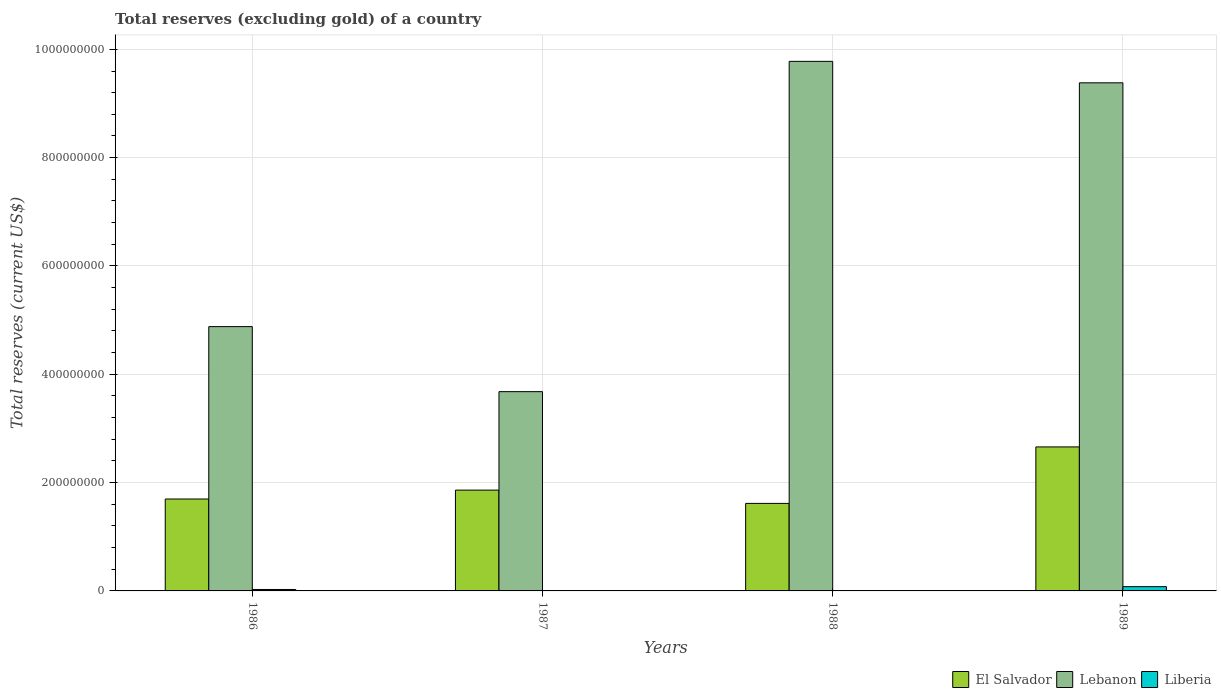How many different coloured bars are there?
Provide a succinct answer. 3. How many groups of bars are there?
Your response must be concise. 4. Are the number of bars on each tick of the X-axis equal?
Offer a terse response. Yes. What is the label of the 4th group of bars from the left?
Provide a succinct answer. 1989. In how many cases, is the number of bars for a given year not equal to the number of legend labels?
Your response must be concise. 0. What is the total reserves (excluding gold) in Liberia in 1988?
Provide a short and direct response. 3.80e+05. Across all years, what is the maximum total reserves (excluding gold) in El Salvador?
Your answer should be compact. 2.66e+08. Across all years, what is the minimum total reserves (excluding gold) in El Salvador?
Give a very brief answer. 1.62e+08. What is the total total reserves (excluding gold) in Lebanon in the graph?
Your answer should be very brief. 2.77e+09. What is the difference between the total reserves (excluding gold) in Lebanon in 1986 and that in 1987?
Keep it short and to the point. 1.20e+08. What is the difference between the total reserves (excluding gold) in Liberia in 1986 and the total reserves (excluding gold) in Lebanon in 1989?
Keep it short and to the point. -9.36e+08. What is the average total reserves (excluding gold) in Lebanon per year?
Provide a short and direct response. 6.93e+08. In the year 1988, what is the difference between the total reserves (excluding gold) in Lebanon and total reserves (excluding gold) in El Salvador?
Provide a short and direct response. 8.16e+08. What is the ratio of the total reserves (excluding gold) in Lebanon in 1986 to that in 1988?
Ensure brevity in your answer.  0.5. Is the total reserves (excluding gold) in El Salvador in 1987 less than that in 1988?
Keep it short and to the point. No. What is the difference between the highest and the second highest total reserves (excluding gold) in Lebanon?
Provide a succinct answer. 3.97e+07. What is the difference between the highest and the lowest total reserves (excluding gold) in El Salvador?
Offer a very short reply. 1.04e+08. Is the sum of the total reserves (excluding gold) in Lebanon in 1987 and 1989 greater than the maximum total reserves (excluding gold) in El Salvador across all years?
Offer a terse response. Yes. What does the 1st bar from the left in 1989 represents?
Ensure brevity in your answer.  El Salvador. What does the 2nd bar from the right in 1987 represents?
Keep it short and to the point. Lebanon. How many bars are there?
Provide a short and direct response. 12. Are the values on the major ticks of Y-axis written in scientific E-notation?
Give a very brief answer. No. Where does the legend appear in the graph?
Offer a terse response. Bottom right. How are the legend labels stacked?
Your response must be concise. Horizontal. What is the title of the graph?
Make the answer very short. Total reserves (excluding gold) of a country. What is the label or title of the X-axis?
Ensure brevity in your answer.  Years. What is the label or title of the Y-axis?
Keep it short and to the point. Total reserves (current US$). What is the Total reserves (current US$) in El Salvador in 1986?
Ensure brevity in your answer.  1.70e+08. What is the Total reserves (current US$) in Lebanon in 1986?
Offer a very short reply. 4.88e+08. What is the Total reserves (current US$) in Liberia in 1986?
Ensure brevity in your answer.  2.66e+06. What is the Total reserves (current US$) in El Salvador in 1987?
Provide a succinct answer. 1.86e+08. What is the Total reserves (current US$) in Lebanon in 1987?
Give a very brief answer. 3.68e+08. What is the Total reserves (current US$) in Liberia in 1987?
Your answer should be compact. 5.10e+05. What is the Total reserves (current US$) in El Salvador in 1988?
Offer a very short reply. 1.62e+08. What is the Total reserves (current US$) of Lebanon in 1988?
Your answer should be very brief. 9.78e+08. What is the Total reserves (current US$) of Liberia in 1988?
Keep it short and to the point. 3.80e+05. What is the Total reserves (current US$) of El Salvador in 1989?
Your answer should be very brief. 2.66e+08. What is the Total reserves (current US$) of Lebanon in 1989?
Your response must be concise. 9.38e+08. What is the Total reserves (current US$) in Liberia in 1989?
Give a very brief answer. 7.88e+06. Across all years, what is the maximum Total reserves (current US$) of El Salvador?
Keep it short and to the point. 2.66e+08. Across all years, what is the maximum Total reserves (current US$) in Lebanon?
Your response must be concise. 9.78e+08. Across all years, what is the maximum Total reserves (current US$) in Liberia?
Provide a short and direct response. 7.88e+06. Across all years, what is the minimum Total reserves (current US$) in El Salvador?
Provide a succinct answer. 1.62e+08. Across all years, what is the minimum Total reserves (current US$) in Lebanon?
Your answer should be compact. 3.68e+08. Across all years, what is the minimum Total reserves (current US$) in Liberia?
Offer a very short reply. 3.80e+05. What is the total Total reserves (current US$) in El Salvador in the graph?
Offer a terse response. 7.83e+08. What is the total Total reserves (current US$) of Lebanon in the graph?
Give a very brief answer. 2.77e+09. What is the total Total reserves (current US$) of Liberia in the graph?
Make the answer very short. 1.14e+07. What is the difference between the Total reserves (current US$) of El Salvador in 1986 and that in 1987?
Provide a succinct answer. -1.64e+07. What is the difference between the Total reserves (current US$) of Lebanon in 1986 and that in 1987?
Give a very brief answer. 1.20e+08. What is the difference between the Total reserves (current US$) of Liberia in 1986 and that in 1987?
Provide a short and direct response. 2.15e+06. What is the difference between the Total reserves (current US$) of El Salvador in 1986 and that in 1988?
Offer a very short reply. 8.09e+06. What is the difference between the Total reserves (current US$) of Lebanon in 1986 and that in 1988?
Keep it short and to the point. -4.90e+08. What is the difference between the Total reserves (current US$) in Liberia in 1986 and that in 1988?
Your response must be concise. 2.28e+06. What is the difference between the Total reserves (current US$) in El Salvador in 1986 and that in 1989?
Your answer should be compact. -9.62e+07. What is the difference between the Total reserves (current US$) of Lebanon in 1986 and that in 1989?
Your answer should be compact. -4.50e+08. What is the difference between the Total reserves (current US$) of Liberia in 1986 and that in 1989?
Your response must be concise. -5.22e+06. What is the difference between the Total reserves (current US$) in El Salvador in 1987 and that in 1988?
Your answer should be very brief. 2.45e+07. What is the difference between the Total reserves (current US$) of Lebanon in 1987 and that in 1988?
Ensure brevity in your answer.  -6.10e+08. What is the difference between the Total reserves (current US$) of Liberia in 1987 and that in 1988?
Offer a terse response. 1.29e+05. What is the difference between the Total reserves (current US$) in El Salvador in 1987 and that in 1989?
Ensure brevity in your answer.  -7.98e+07. What is the difference between the Total reserves (current US$) of Lebanon in 1987 and that in 1989?
Provide a short and direct response. -5.70e+08. What is the difference between the Total reserves (current US$) of Liberia in 1987 and that in 1989?
Provide a succinct answer. -7.37e+06. What is the difference between the Total reserves (current US$) of El Salvador in 1988 and that in 1989?
Your answer should be compact. -1.04e+08. What is the difference between the Total reserves (current US$) in Lebanon in 1988 and that in 1989?
Provide a short and direct response. 3.97e+07. What is the difference between the Total reserves (current US$) of Liberia in 1988 and that in 1989?
Keep it short and to the point. -7.50e+06. What is the difference between the Total reserves (current US$) in El Salvador in 1986 and the Total reserves (current US$) in Lebanon in 1987?
Your answer should be very brief. -1.98e+08. What is the difference between the Total reserves (current US$) of El Salvador in 1986 and the Total reserves (current US$) of Liberia in 1987?
Offer a terse response. 1.69e+08. What is the difference between the Total reserves (current US$) in Lebanon in 1986 and the Total reserves (current US$) in Liberia in 1987?
Offer a terse response. 4.88e+08. What is the difference between the Total reserves (current US$) of El Salvador in 1986 and the Total reserves (current US$) of Lebanon in 1988?
Ensure brevity in your answer.  -8.08e+08. What is the difference between the Total reserves (current US$) in El Salvador in 1986 and the Total reserves (current US$) in Liberia in 1988?
Your answer should be compact. 1.69e+08. What is the difference between the Total reserves (current US$) of Lebanon in 1986 and the Total reserves (current US$) of Liberia in 1988?
Your response must be concise. 4.88e+08. What is the difference between the Total reserves (current US$) of El Salvador in 1986 and the Total reserves (current US$) of Lebanon in 1989?
Offer a terse response. -7.68e+08. What is the difference between the Total reserves (current US$) in El Salvador in 1986 and the Total reserves (current US$) in Liberia in 1989?
Offer a very short reply. 1.62e+08. What is the difference between the Total reserves (current US$) in Lebanon in 1986 and the Total reserves (current US$) in Liberia in 1989?
Provide a short and direct response. 4.80e+08. What is the difference between the Total reserves (current US$) in El Salvador in 1987 and the Total reserves (current US$) in Lebanon in 1988?
Offer a very short reply. -7.92e+08. What is the difference between the Total reserves (current US$) of El Salvador in 1987 and the Total reserves (current US$) of Liberia in 1988?
Offer a terse response. 1.86e+08. What is the difference between the Total reserves (current US$) of Lebanon in 1987 and the Total reserves (current US$) of Liberia in 1988?
Your response must be concise. 3.68e+08. What is the difference between the Total reserves (current US$) of El Salvador in 1987 and the Total reserves (current US$) of Lebanon in 1989?
Give a very brief answer. -7.52e+08. What is the difference between the Total reserves (current US$) in El Salvador in 1987 and the Total reserves (current US$) in Liberia in 1989?
Keep it short and to the point. 1.78e+08. What is the difference between the Total reserves (current US$) in Lebanon in 1987 and the Total reserves (current US$) in Liberia in 1989?
Your answer should be very brief. 3.60e+08. What is the difference between the Total reserves (current US$) in El Salvador in 1988 and the Total reserves (current US$) in Lebanon in 1989?
Your response must be concise. -7.77e+08. What is the difference between the Total reserves (current US$) of El Salvador in 1988 and the Total reserves (current US$) of Liberia in 1989?
Offer a very short reply. 1.54e+08. What is the difference between the Total reserves (current US$) of Lebanon in 1988 and the Total reserves (current US$) of Liberia in 1989?
Make the answer very short. 9.70e+08. What is the average Total reserves (current US$) of El Salvador per year?
Your answer should be compact. 1.96e+08. What is the average Total reserves (current US$) of Lebanon per year?
Keep it short and to the point. 6.93e+08. What is the average Total reserves (current US$) of Liberia per year?
Give a very brief answer. 2.86e+06. In the year 1986, what is the difference between the Total reserves (current US$) of El Salvador and Total reserves (current US$) of Lebanon?
Your answer should be very brief. -3.18e+08. In the year 1986, what is the difference between the Total reserves (current US$) in El Salvador and Total reserves (current US$) in Liberia?
Ensure brevity in your answer.  1.67e+08. In the year 1986, what is the difference between the Total reserves (current US$) in Lebanon and Total reserves (current US$) in Liberia?
Offer a very short reply. 4.85e+08. In the year 1987, what is the difference between the Total reserves (current US$) of El Salvador and Total reserves (current US$) of Lebanon?
Offer a very short reply. -1.82e+08. In the year 1987, what is the difference between the Total reserves (current US$) in El Salvador and Total reserves (current US$) in Liberia?
Offer a very short reply. 1.86e+08. In the year 1987, what is the difference between the Total reserves (current US$) in Lebanon and Total reserves (current US$) in Liberia?
Make the answer very short. 3.67e+08. In the year 1988, what is the difference between the Total reserves (current US$) of El Salvador and Total reserves (current US$) of Lebanon?
Your response must be concise. -8.16e+08. In the year 1988, what is the difference between the Total reserves (current US$) in El Salvador and Total reserves (current US$) in Liberia?
Ensure brevity in your answer.  1.61e+08. In the year 1988, what is the difference between the Total reserves (current US$) in Lebanon and Total reserves (current US$) in Liberia?
Ensure brevity in your answer.  9.77e+08. In the year 1989, what is the difference between the Total reserves (current US$) of El Salvador and Total reserves (current US$) of Lebanon?
Make the answer very short. -6.72e+08. In the year 1989, what is the difference between the Total reserves (current US$) of El Salvador and Total reserves (current US$) of Liberia?
Your answer should be compact. 2.58e+08. In the year 1989, what is the difference between the Total reserves (current US$) in Lebanon and Total reserves (current US$) in Liberia?
Your response must be concise. 9.30e+08. What is the ratio of the Total reserves (current US$) of El Salvador in 1986 to that in 1987?
Give a very brief answer. 0.91. What is the ratio of the Total reserves (current US$) of Lebanon in 1986 to that in 1987?
Your answer should be very brief. 1.33. What is the ratio of the Total reserves (current US$) in Liberia in 1986 to that in 1987?
Keep it short and to the point. 5.22. What is the ratio of the Total reserves (current US$) in El Salvador in 1986 to that in 1988?
Give a very brief answer. 1.05. What is the ratio of the Total reserves (current US$) in Lebanon in 1986 to that in 1988?
Provide a short and direct response. 0.5. What is the ratio of the Total reserves (current US$) in Liberia in 1986 to that in 1988?
Give a very brief answer. 6.99. What is the ratio of the Total reserves (current US$) of El Salvador in 1986 to that in 1989?
Keep it short and to the point. 0.64. What is the ratio of the Total reserves (current US$) in Lebanon in 1986 to that in 1989?
Offer a very short reply. 0.52. What is the ratio of the Total reserves (current US$) of Liberia in 1986 to that in 1989?
Your answer should be very brief. 0.34. What is the ratio of the Total reserves (current US$) of El Salvador in 1987 to that in 1988?
Offer a very short reply. 1.15. What is the ratio of the Total reserves (current US$) of Lebanon in 1987 to that in 1988?
Provide a succinct answer. 0.38. What is the ratio of the Total reserves (current US$) in Liberia in 1987 to that in 1988?
Your response must be concise. 1.34. What is the ratio of the Total reserves (current US$) of Lebanon in 1987 to that in 1989?
Ensure brevity in your answer.  0.39. What is the ratio of the Total reserves (current US$) of Liberia in 1987 to that in 1989?
Your answer should be compact. 0.06. What is the ratio of the Total reserves (current US$) of El Salvador in 1988 to that in 1989?
Your response must be concise. 0.61. What is the ratio of the Total reserves (current US$) in Lebanon in 1988 to that in 1989?
Ensure brevity in your answer.  1.04. What is the ratio of the Total reserves (current US$) of Liberia in 1988 to that in 1989?
Your response must be concise. 0.05. What is the difference between the highest and the second highest Total reserves (current US$) in El Salvador?
Ensure brevity in your answer.  7.98e+07. What is the difference between the highest and the second highest Total reserves (current US$) in Lebanon?
Your response must be concise. 3.97e+07. What is the difference between the highest and the second highest Total reserves (current US$) of Liberia?
Offer a very short reply. 5.22e+06. What is the difference between the highest and the lowest Total reserves (current US$) in El Salvador?
Give a very brief answer. 1.04e+08. What is the difference between the highest and the lowest Total reserves (current US$) of Lebanon?
Offer a very short reply. 6.10e+08. What is the difference between the highest and the lowest Total reserves (current US$) in Liberia?
Offer a terse response. 7.50e+06. 